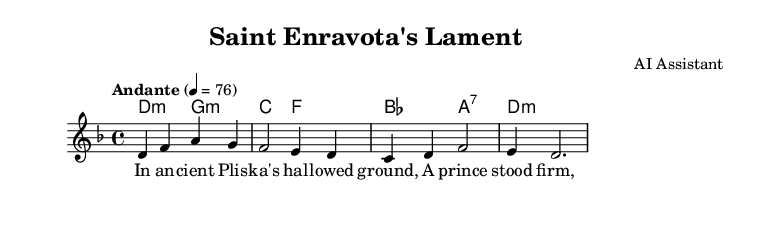what is the key signature of this music? The key signature is D minor, which is indicated by one flat (B flat) in the key signature at the beginning of the staff.
Answer: D minor what is the time signature of this music? The time signature is indicated by the fraction at the beginning of the music, which shows that there are four beats per measure and the quarter note gets one beat.
Answer: 4/4 what is the tempo marking in this music? The tempo marking is indicated in the score, specifying the speed at which the piece should be played. In this case, it indicates an Andante tempo at 76 beats per minute.
Answer: Andante, 76 how many measures are in the melody section? To find the number of measures, we count the vertical bar lines in the melody section. There are a total of four vertical bar lines, indicating four measures.
Answer: 4 what type of harmony is primarily used in this piece? The harmony section mainly consists of minor chords, which can be identified by the use of 'm' symbol in the chord names, indicating their minor quality.
Answer: Minor which saint is honored in this song? The title of the piece reveals that it is titled "Saint Enravota's Lament," indicating that it honors Saint Enravota specifically.
Answer: Saint Enravota how does the lyrical theme reflect on the saint's character? The lyrics reference standing firm in faith, suggesting that the song honors the steadfastness and dedication of Saint Enravota in the face of challenges, characteristic of many saints.
Answer: Steadfastness 